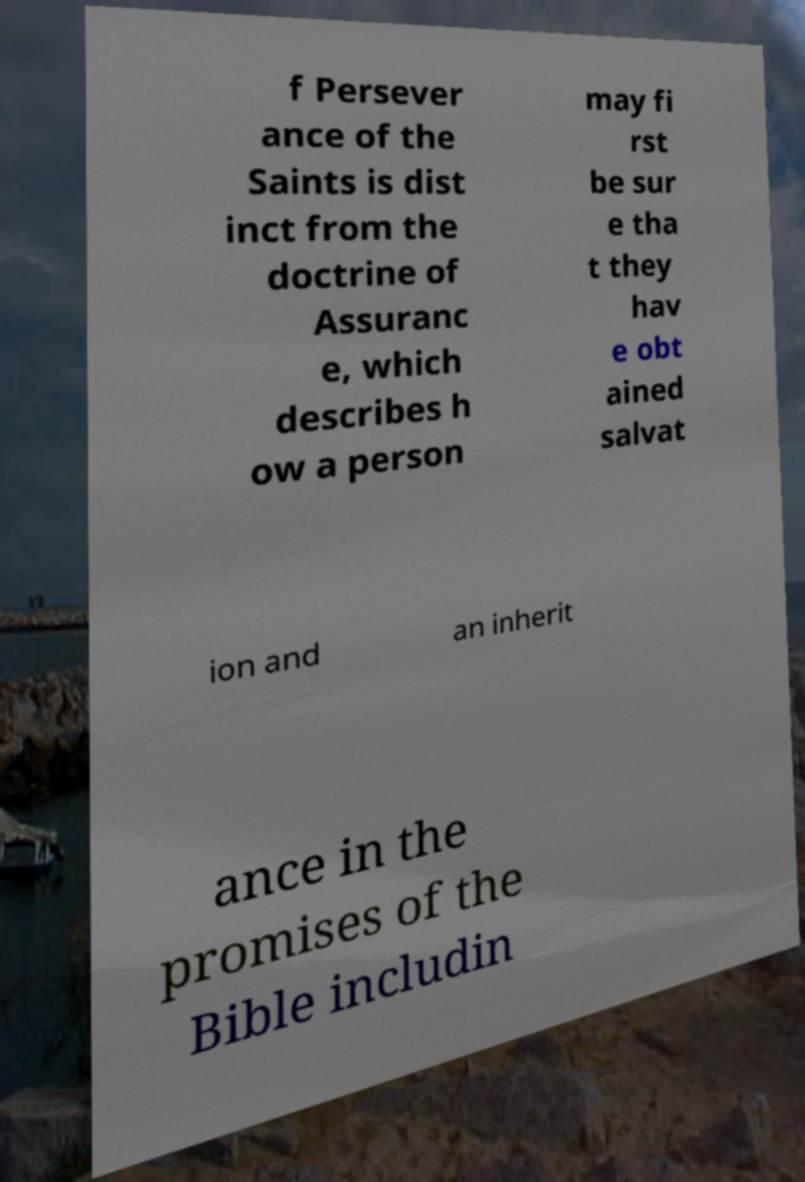Please identify and transcribe the text found in this image. f Persever ance of the Saints is dist inct from the doctrine of Assuranc e, which describes h ow a person may fi rst be sur e tha t they hav e obt ained salvat ion and an inherit ance in the promises of the Bible includin 